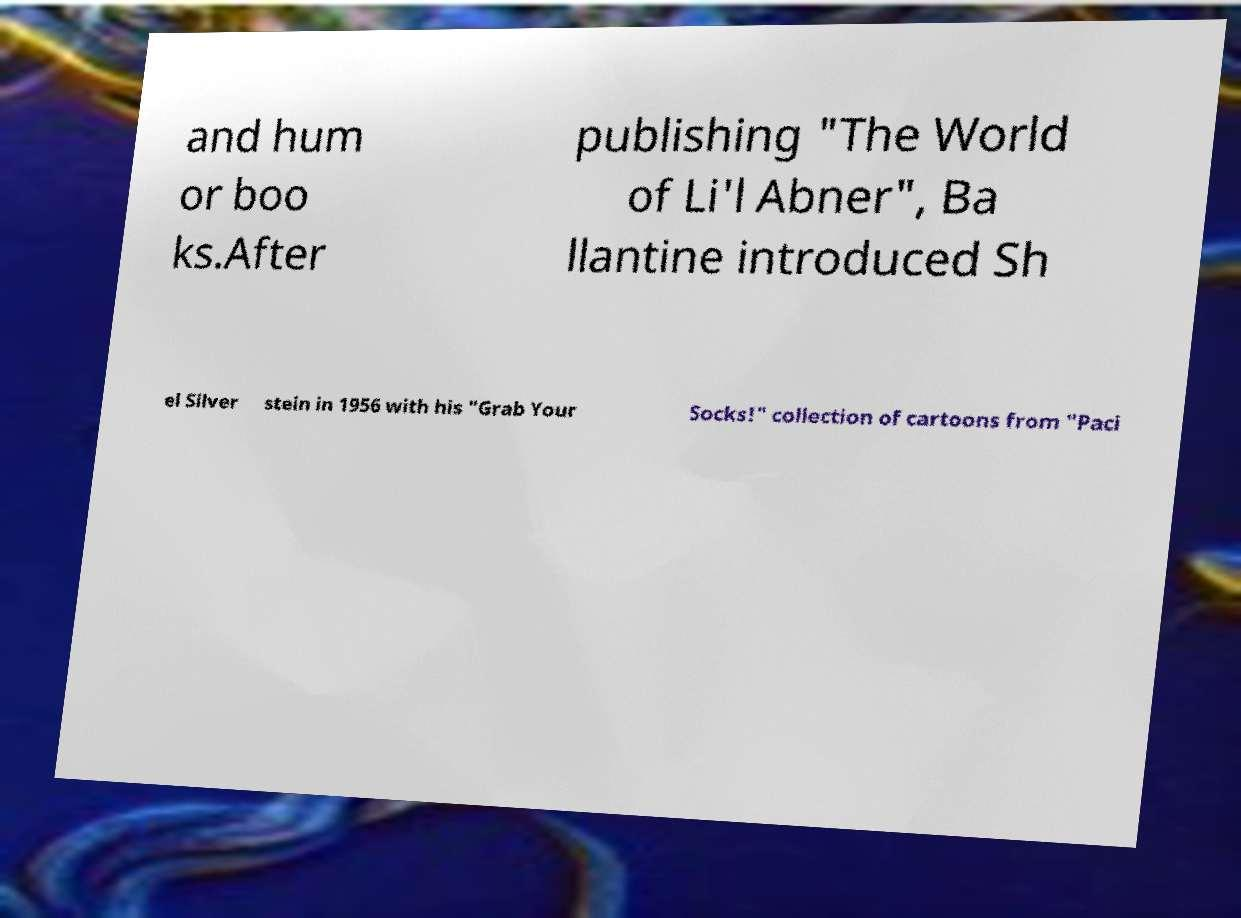Can you read and provide the text displayed in the image?This photo seems to have some interesting text. Can you extract and type it out for me? and hum or boo ks.After publishing "The World of Li'l Abner", Ba llantine introduced Sh el Silver stein in 1956 with his "Grab Your Socks!" collection of cartoons from "Paci 